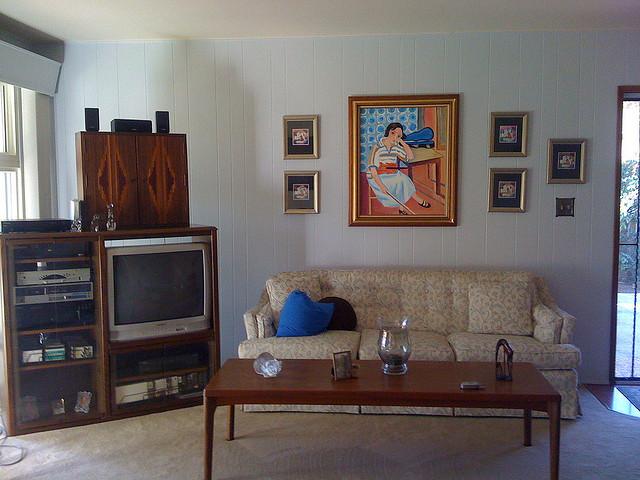How many vases are there?
Concise answer only. 1. Would there be an echo in this room?
Write a very short answer. No. What is the floor type?
Give a very brief answer. Carpet. Does this room have carpet?
Concise answer only. Yes. What color is the couch on the left?
Be succinct. Tan. What pattern is on the couch?
Concise answer only. Floral. What is on the table?
Concise answer only. Vase. What color are the sofas?
Answer briefly. Beige. How many pillows are on the sofa?
Give a very brief answer. 4. Is there any Christmas decoration on the windows?
Give a very brief answer. No. How many pictures do you see?
Answer briefly. 6. Where is the TV?
Keep it brief. Living room. Where is the painting?
Keep it brief. Wall. Why is the coffee table empty?
Quick response, please. It isn't. What is placed on the wooden table?
Be succinct. Vase. Does this room appear clean?
Answer briefly. Yes. What type of art is represented in the picture on the wall?
Answer briefly. Abstract. What is on the painting?
Concise answer only. Woman. What kind of wall does this place have?
Answer briefly. White. Is the TV on?
Give a very brief answer. No. Is there a window in this scene?
Be succinct. Yes. Is there a mirror in this room?
Give a very brief answer. No. How many mirrors are hanging on the wall?
Quick response, please. 0. How many vases are on the table?
Keep it brief. 1. What are the floors made out of?
Quick response, please. Carpet. Are there flowers in the vase?
Concise answer only. No. What room is this?
Answer briefly. Living room. Is there a fireplace?
Be succinct. No. How many rooms is this?
Concise answer only. 1. What color is the couch?
Answer briefly. Beige. Is there wine in the picture?
Keep it brief. No. What color is the after picture?
Write a very short answer. Brown. 